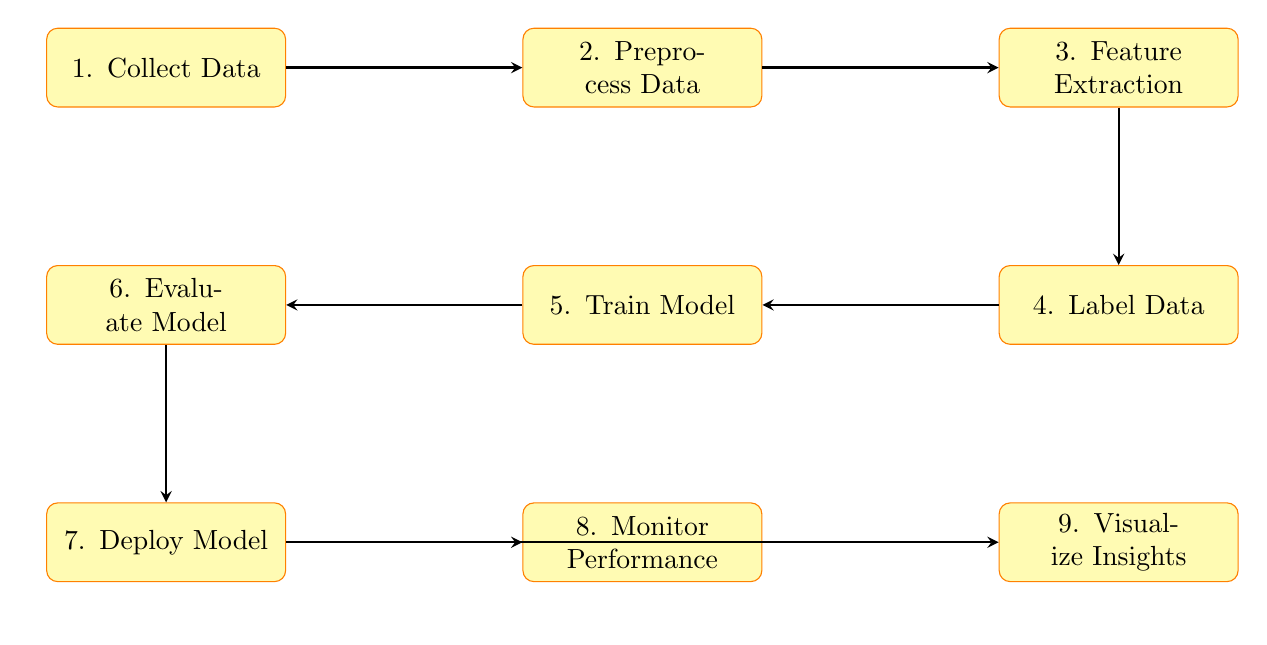What is the first step in the diagram? The diagram shows a series of steps for customer sentiment analysis, with the first step labeled as "Collect Data," indicating that gathering reviews is the initial action.
Answer: Collect Data How many processing steps are represented in the diagram? By counting the labeled rectangles in the diagram, we can identify that there are nine distinct processing steps depicted, from data collection to visualization.
Answer: Nine What node comes after "Deploy Model"? To answer this question, we look at the diagram and see the flow of arrows that connect the nodes. The node immediately following "Deploy Model" is "Monitor Performance."
Answer: Monitor Performance What technique is mentioned for feature extraction? The diagram specifies that feature extraction can be achieved using techniques like TF-IDF or Word2Vec, detailing the methods listed under the "Feature Extraction" node.
Answer: TF-IDF, Word2Vec What is the purpose of the "Visualize Insights" step? The diagram describes the "Visualize Insights" step as using tools like Tableau or Power BI to visualize sentiment trends, indicating its role in analysis and decision-making.
Answer: Visualize sentiment trends Which step involves assessing accuracy, precision, recall, and F1-score? The diagram shows that the "Evaluate Model" step focuses on assessing various performance metrics, including accuracy, precision, recall, and F1-score, making it distinct in this context.
Answer: Evaluate Model What is done in the "Label Data" step? In this step, the data is classified into Positive, Neutral, and Negative categories, which is a key part of the sentiment analysis process outlined in the diagram.
Answer: Classify reviews Which arrows indicate a flow from "Train Model" to another step? The arrows leading from the "Train Model" node direct the flow to "Evaluate Model," making the relationship between these two steps clear regarding the progression of tasks.
Answer: Evaluate Model What comes before "Preprocess Data"? The diagram clearly indicates that "Collect Data" is the step that precedes "Preprocess Data," establishing the initial action required before any processing occurs.
Answer: Collect Data 